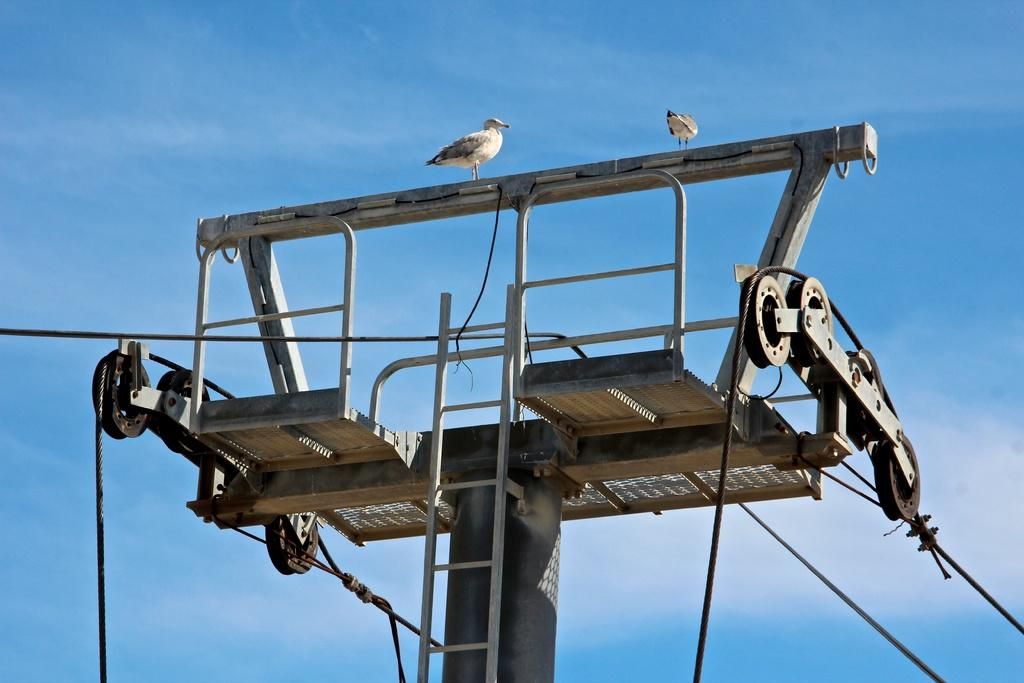What is the main structure in the image? There is a pole in the image. What is attached to the pole? Cables are passing from the pole. Are there any living creatures on the pole? Yes, two birds are sitting on the pole. What can be seen in the background of the image? There is a blue color sky in the background of the image. How many frogs are jumping around the pole in the image? There are no frogs present in the image; it only features a pole, cables, and two birds. Is there any smoke coming from the pole in the image? There is no smoke visible in the image; it only shows a pole, cables, and two birds. 